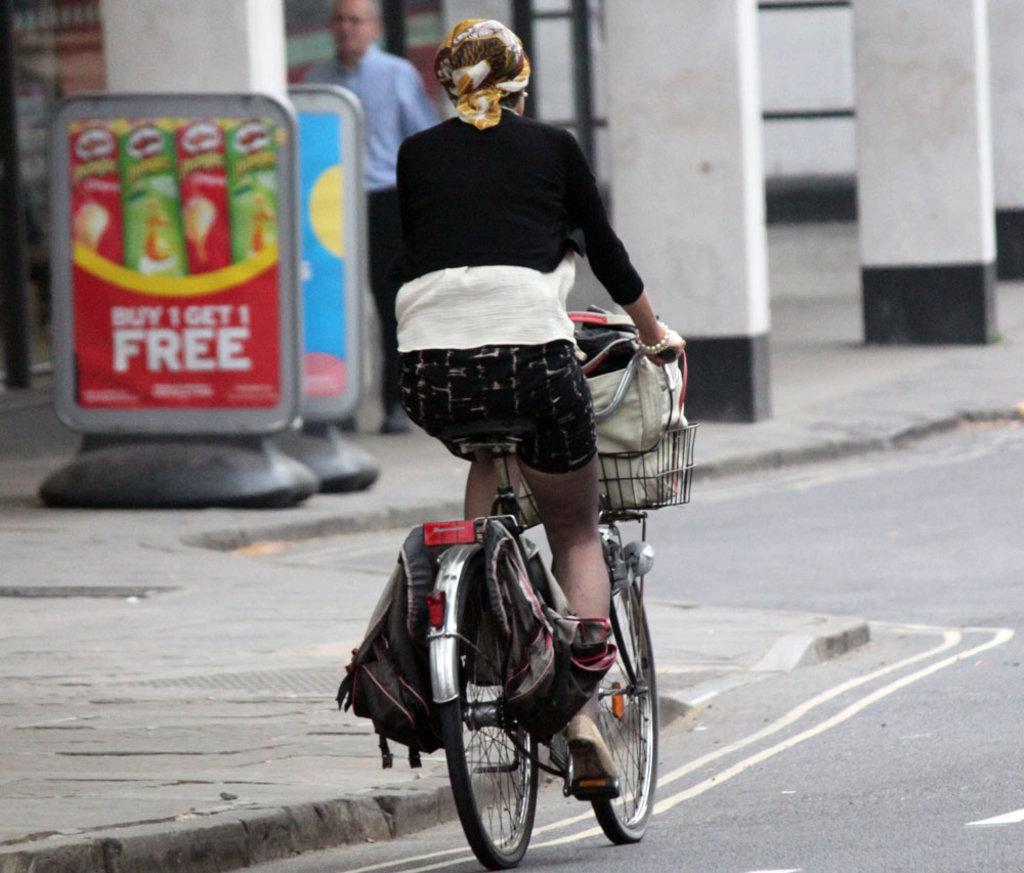Can you describe this image briefly? The image is outside of the city. In the image there is a woman who is riding a bicycle, on bicycle we can see some bags on her basket. On left side there is a man who is standing, we can also see some hoardings on left side,pillars,footpath. On bottom we can see a road which is in black color. 